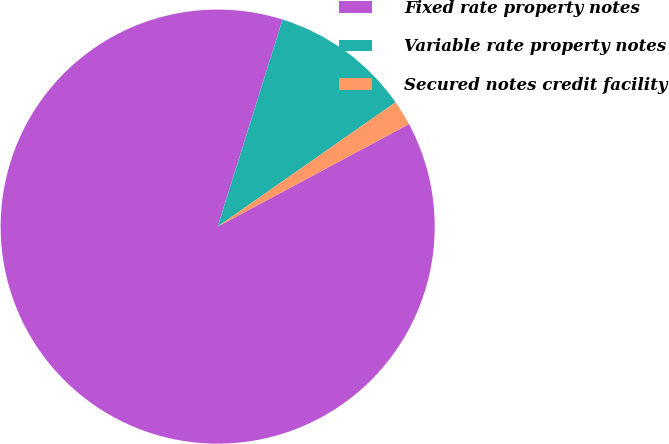Convert chart to OTSL. <chart><loc_0><loc_0><loc_500><loc_500><pie_chart><fcel>Fixed rate property notes<fcel>Variable rate property notes<fcel>Secured notes credit facility<nl><fcel>87.66%<fcel>10.46%<fcel>1.88%<nl></chart> 